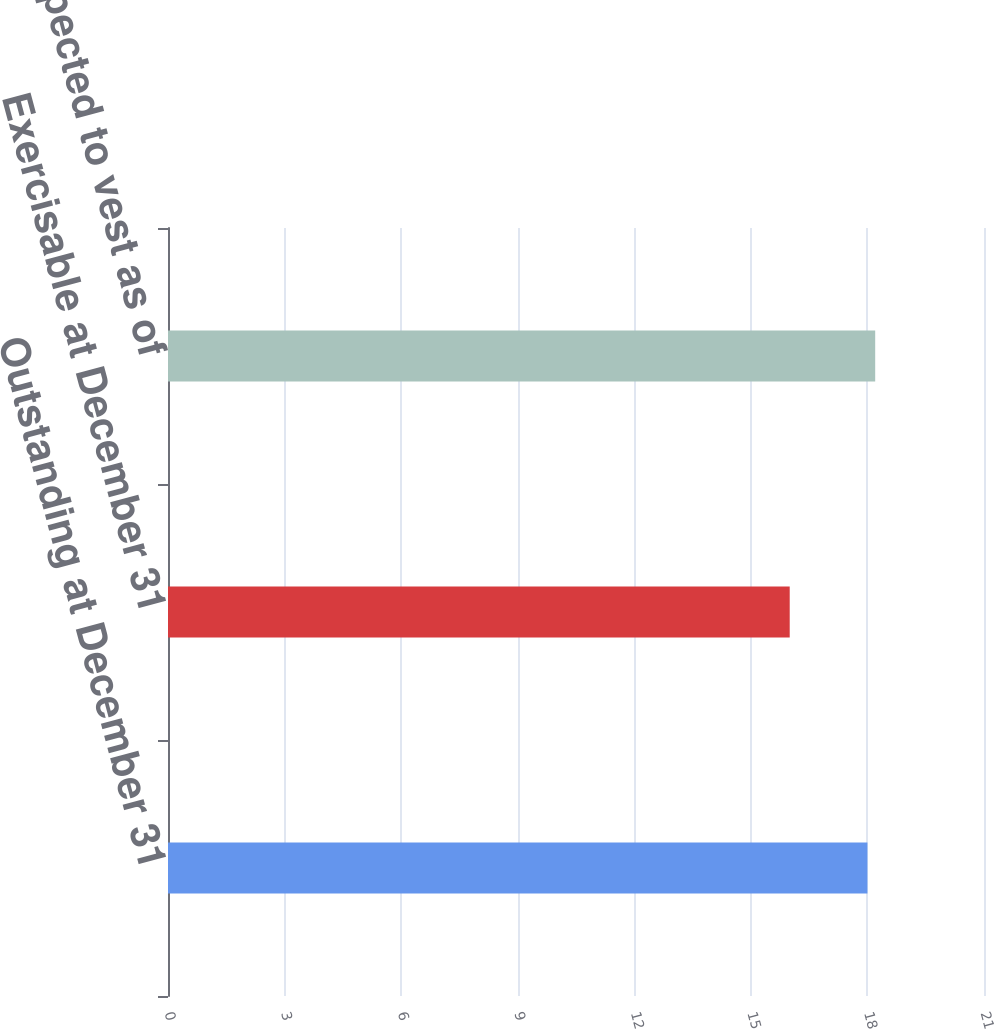<chart> <loc_0><loc_0><loc_500><loc_500><bar_chart><fcel>Outstanding at December 31<fcel>Exercisable at December 31<fcel>Expected to vest as of<nl><fcel>18<fcel>16<fcel>18.2<nl></chart> 